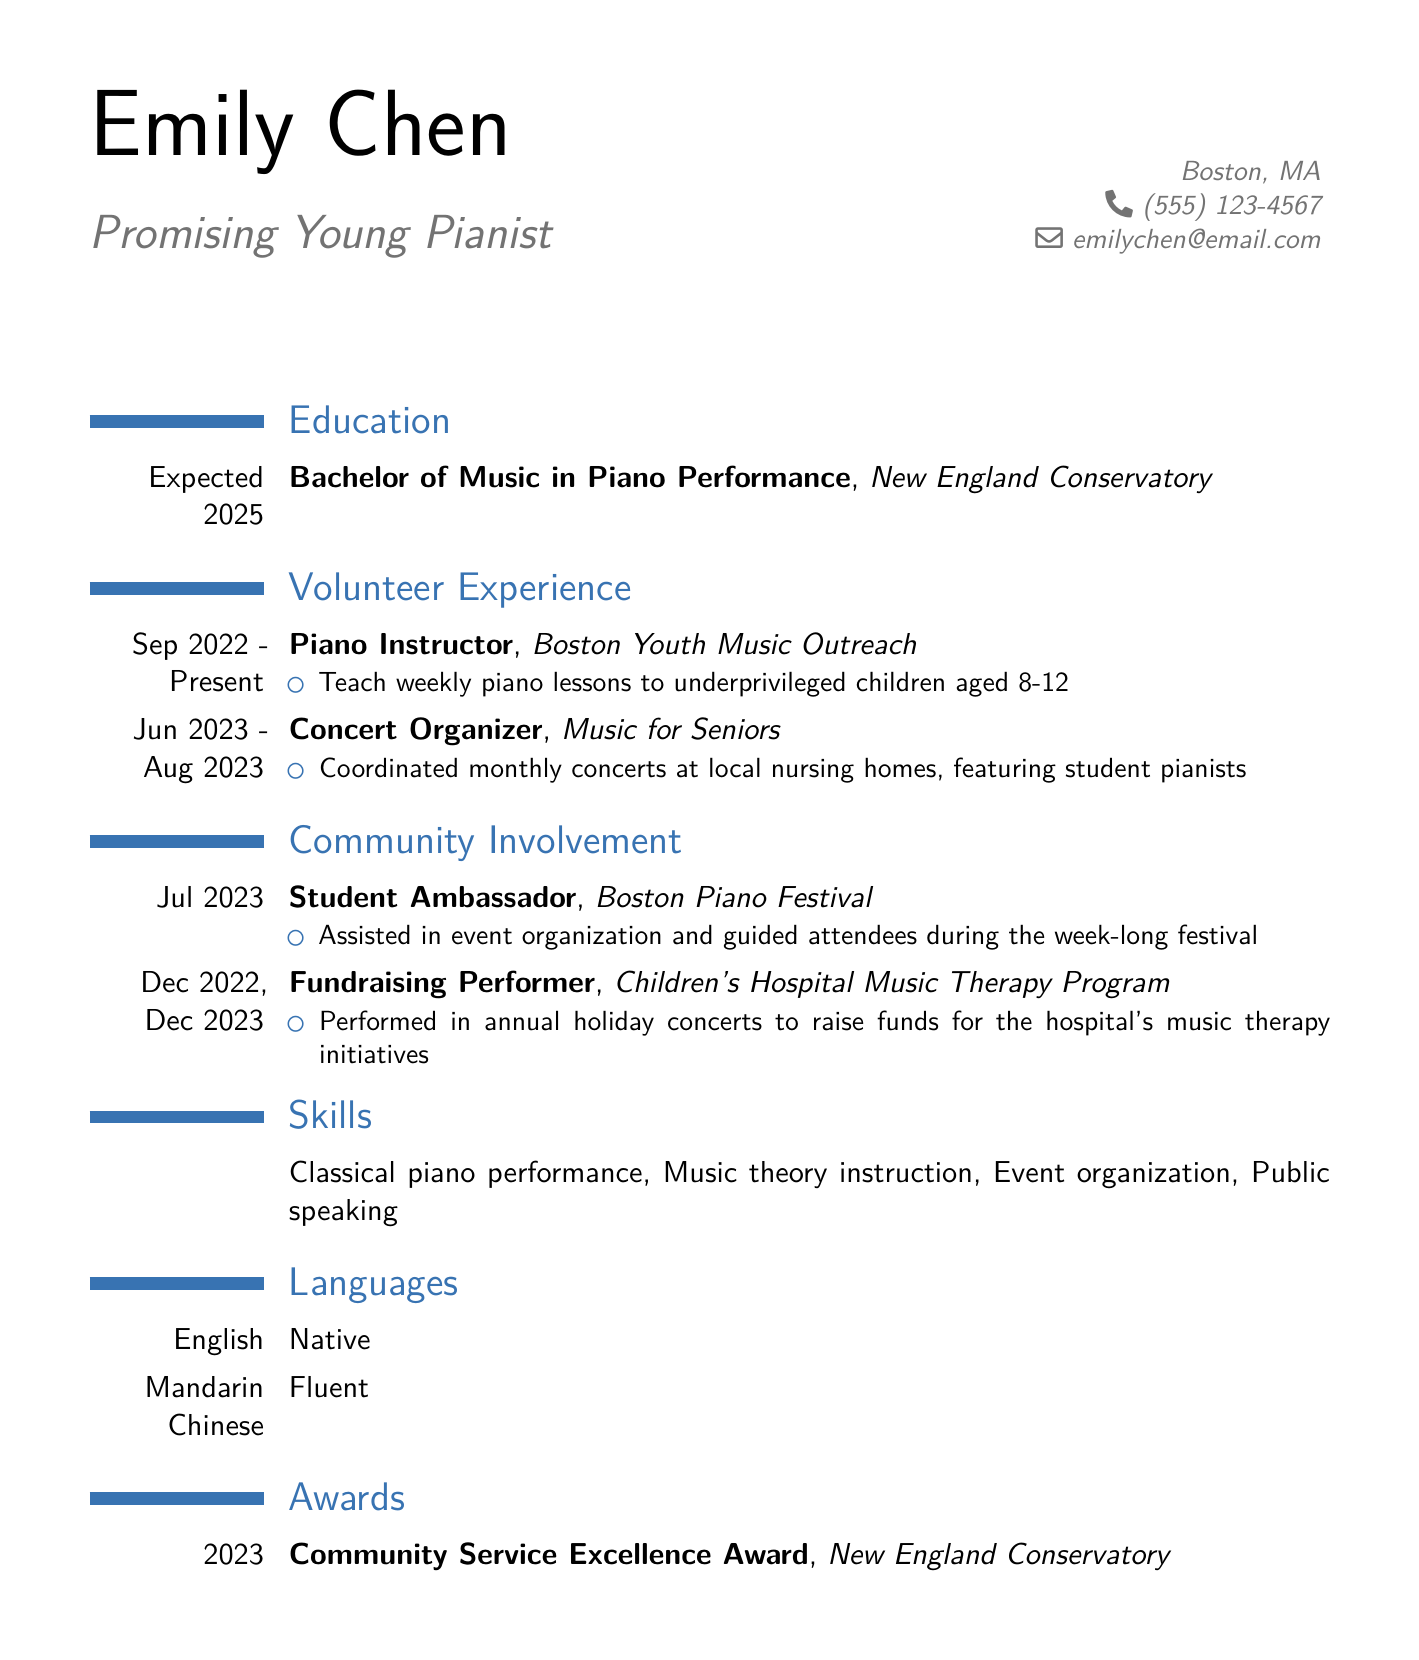What is Emily Chen's degree? Emily Chen's degree is listed under education in the document.
Answer: Bachelor of Music in Piano Performance What is the expected graduation year? The expected graduation year is specified in the education section of the document.
Answer: 2025 Which organization does Emily volunteer for as a Piano Instructor? The document provides details on volunteer experience, specifically listing the organizations involved.
Answer: Boston Youth Music Outreach How long did Emily organize concerts for Music for Seniors? The duration of the position is mentioned in the volunteer experience section.
Answer: Jun 2023 - Aug 2023 What role did Emily have at the Boston Piano Festival? The community involvement section highlights her position at the festival.
Answer: Student Ambassador In which month and year did Emily perform for the Children's Hospital Music Therapy Program? This information is found in the community involvement section, detailing the performance dates.
Answer: Dec 2022, Dec 2023 What award did Emily receive in 2023? The awards section in the document highlights the recognition she received.
Answer: Community Service Excellence Award How many languages does Emily speak? The document lists the languages section, providing a count of the languages known.
Answer: Two What is one of Emily's skills related to music? The skills section identifies specific capabilities of Emily in relation to her music education.
Answer: Classical piano performance 